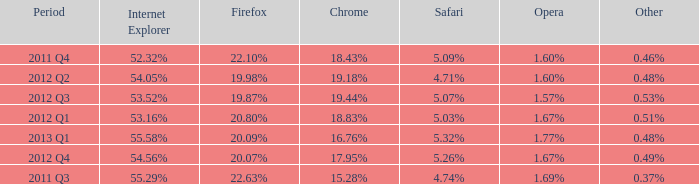What internet explorer has 1.67% as the opera, with 2012 q1 as the period? 53.16%. 